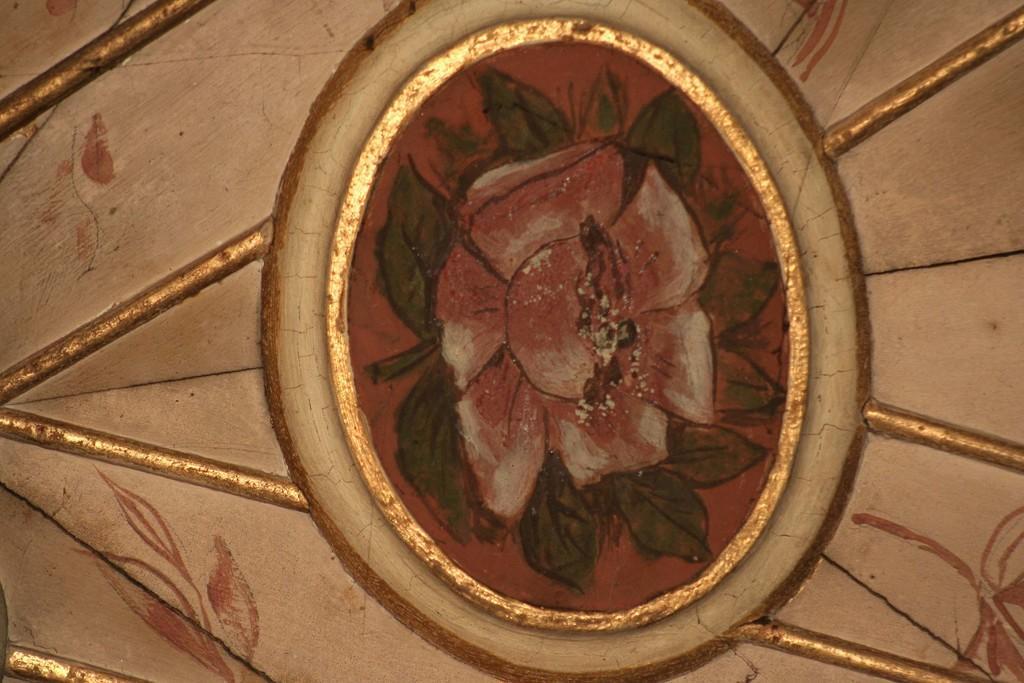Describe this image in one or two sentences. In the image we can see the ceiling of a house and flower design on the ceiling. 